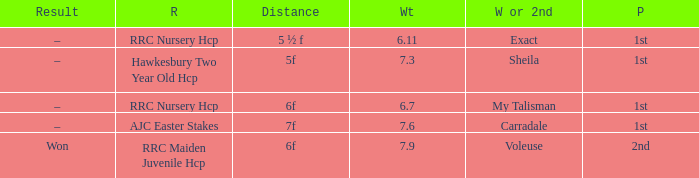What was the distance when the weight was 6.11? 5 ½ f. 